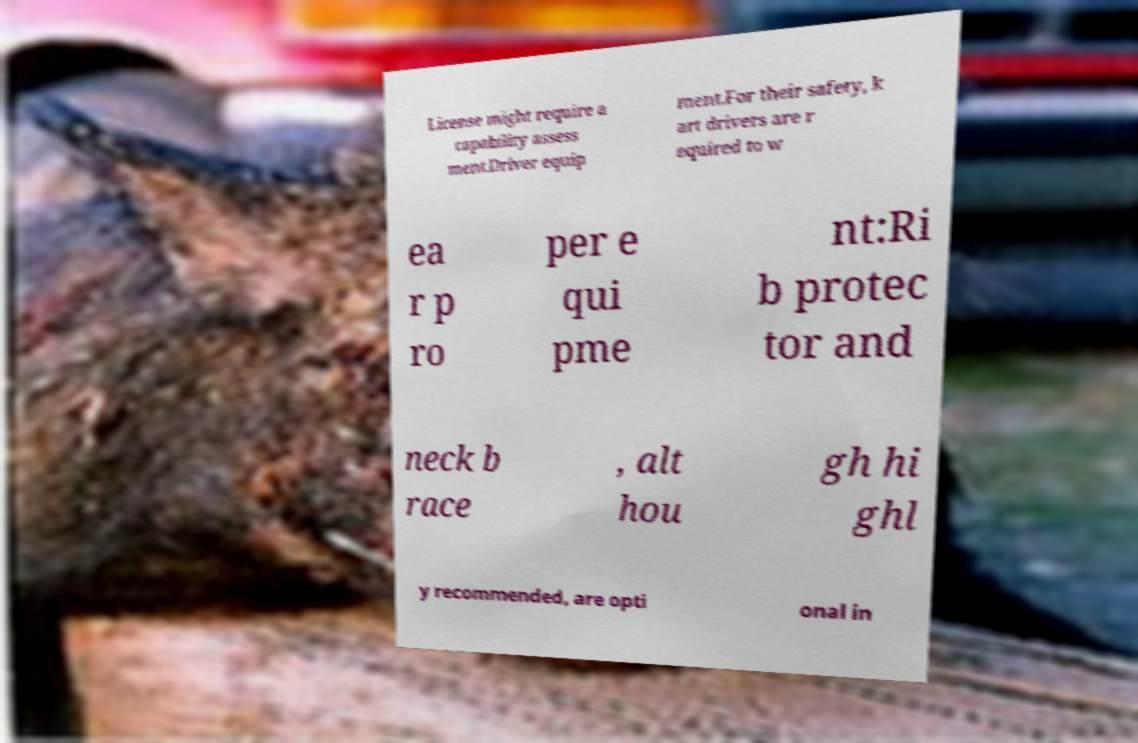What messages or text are displayed in this image? I need them in a readable, typed format. License might require a capability assess ment.Driver equip ment.For their safety, k art drivers are r equired to w ea r p ro per e qui pme nt:Ri b protec tor and neck b race , alt hou gh hi ghl y recommended, are opti onal in 